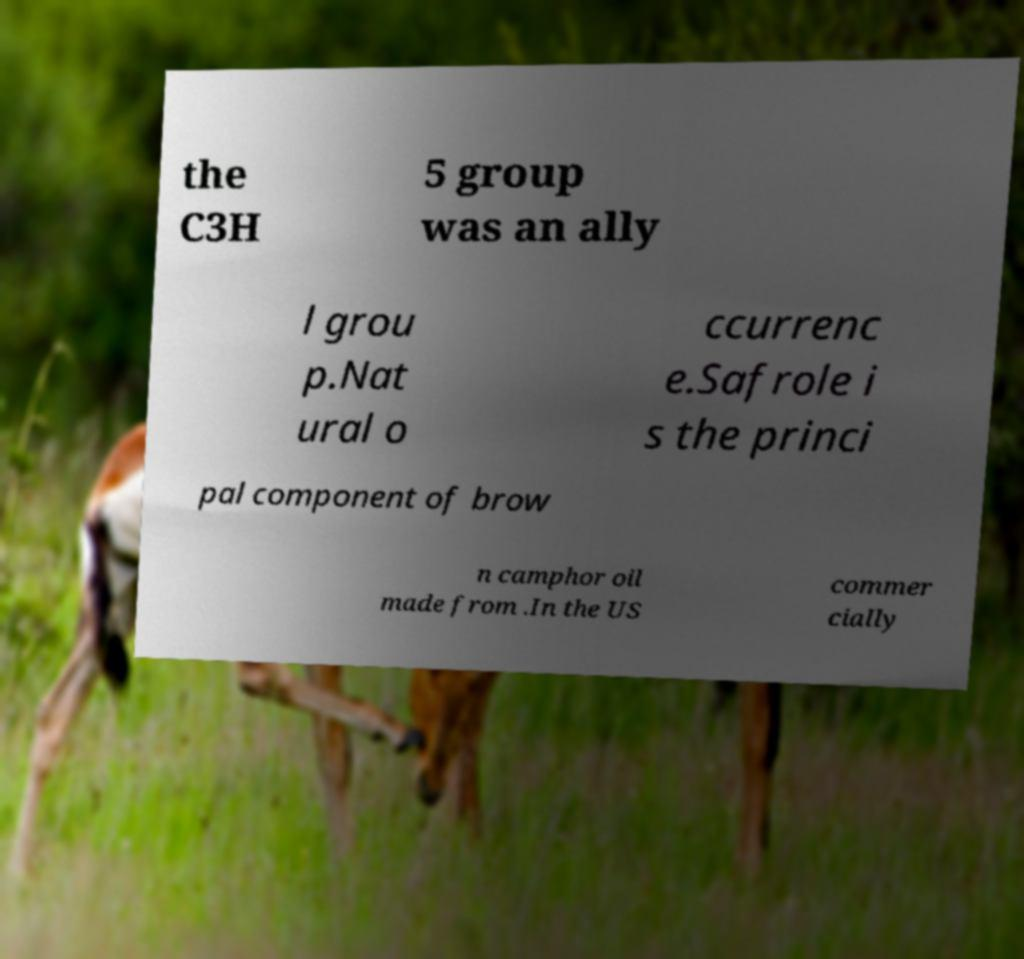Could you extract and type out the text from this image? the C3H 5 group was an ally l grou p.Nat ural o ccurrenc e.Safrole i s the princi pal component of brow n camphor oil made from .In the US commer cially 